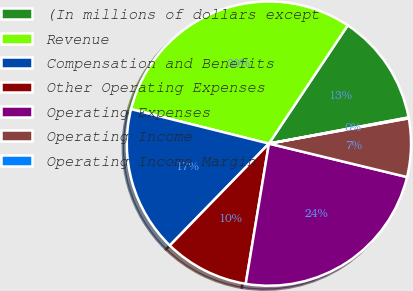<chart> <loc_0><loc_0><loc_500><loc_500><pie_chart><fcel>(In millions of dollars except<fcel>Revenue<fcel>Compensation and Benefits<fcel>Other Operating Expenses<fcel>Operating Expenses<fcel>Operating Income<fcel>Operating Income Margin<nl><fcel>12.7%<fcel>30.46%<fcel>16.62%<fcel>9.67%<fcel>23.83%<fcel>6.63%<fcel>0.1%<nl></chart> 